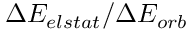Convert formula to latex. <formula><loc_0><loc_0><loc_500><loc_500>\Delta E _ { e l s t a t } / \Delta E _ { o r b }</formula> 